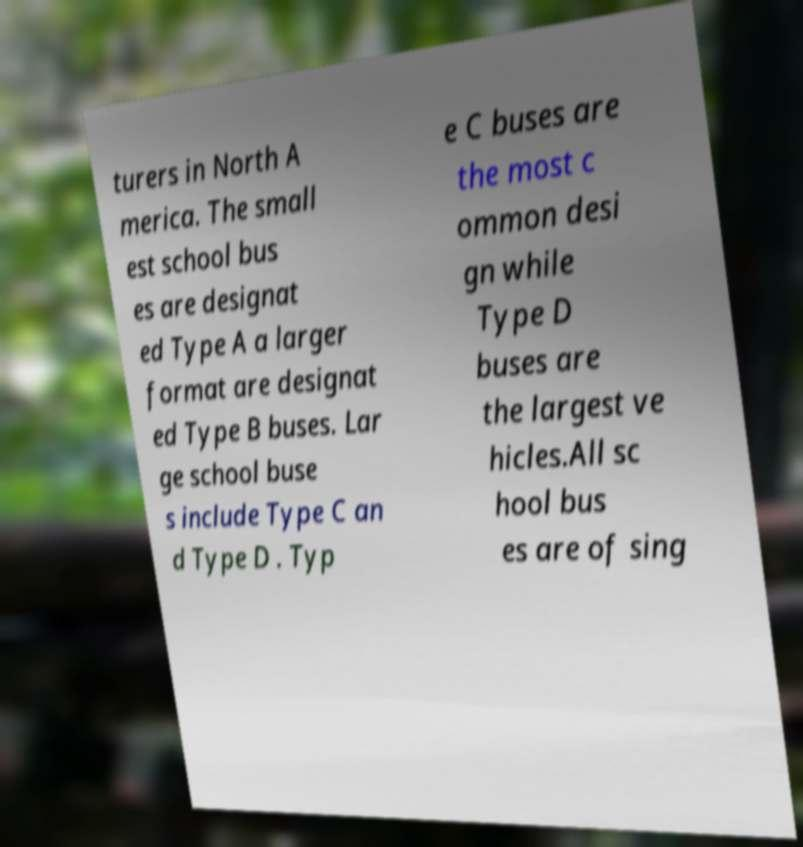Please identify and transcribe the text found in this image. turers in North A merica. The small est school bus es are designat ed Type A a larger format are designat ed Type B buses. Lar ge school buse s include Type C an d Type D . Typ e C buses are the most c ommon desi gn while Type D buses are the largest ve hicles.All sc hool bus es are of sing 